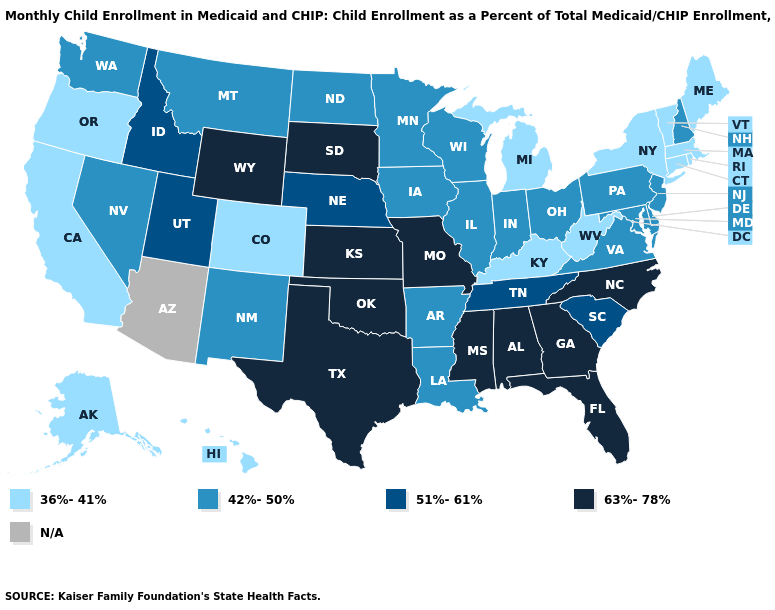Does the map have missing data?
Write a very short answer. Yes. Which states have the highest value in the USA?
Short answer required. Alabama, Florida, Georgia, Kansas, Mississippi, Missouri, North Carolina, Oklahoma, South Dakota, Texas, Wyoming. Among the states that border Montana , which have the lowest value?
Give a very brief answer. North Dakota. What is the value of Utah?
Short answer required. 51%-61%. Name the states that have a value in the range 36%-41%?
Keep it brief. Alaska, California, Colorado, Connecticut, Hawaii, Kentucky, Maine, Massachusetts, Michigan, New York, Oregon, Rhode Island, Vermont, West Virginia. Does the first symbol in the legend represent the smallest category?
Answer briefly. Yes. What is the lowest value in the West?
Be succinct. 36%-41%. Among the states that border Ohio , which have the lowest value?
Write a very short answer. Kentucky, Michigan, West Virginia. Does Massachusetts have the lowest value in the USA?
Concise answer only. Yes. Among the states that border North Dakota , which have the highest value?
Write a very short answer. South Dakota. What is the value of New Hampshire?
Keep it brief. 42%-50%. Which states have the lowest value in the USA?
Keep it brief. Alaska, California, Colorado, Connecticut, Hawaii, Kentucky, Maine, Massachusetts, Michigan, New York, Oregon, Rhode Island, Vermont, West Virginia. Does Georgia have the highest value in the USA?
Write a very short answer. Yes. Name the states that have a value in the range 36%-41%?
Answer briefly. Alaska, California, Colorado, Connecticut, Hawaii, Kentucky, Maine, Massachusetts, Michigan, New York, Oregon, Rhode Island, Vermont, West Virginia. Name the states that have a value in the range 63%-78%?
Answer briefly. Alabama, Florida, Georgia, Kansas, Mississippi, Missouri, North Carolina, Oklahoma, South Dakota, Texas, Wyoming. 